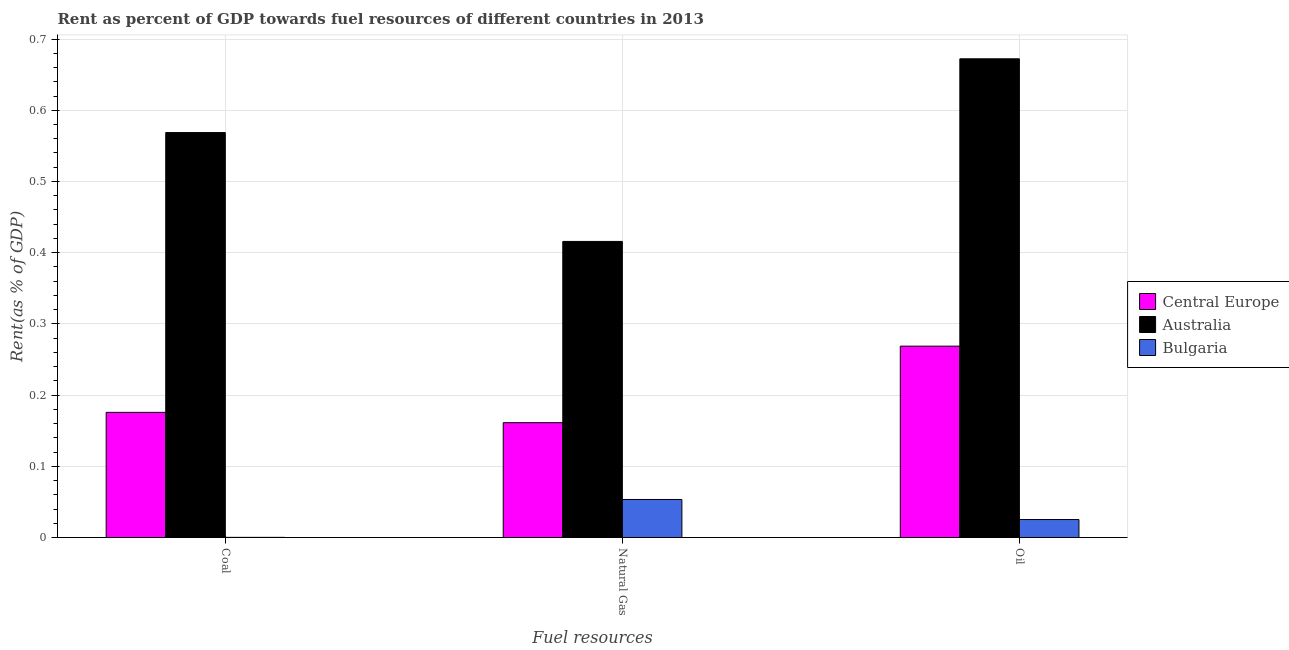Are the number of bars per tick equal to the number of legend labels?
Keep it short and to the point. Yes. How many bars are there on the 3rd tick from the left?
Your answer should be compact. 3. What is the label of the 1st group of bars from the left?
Provide a short and direct response. Coal. What is the rent towards oil in Central Europe?
Make the answer very short. 0.27. Across all countries, what is the maximum rent towards natural gas?
Your answer should be very brief. 0.42. Across all countries, what is the minimum rent towards coal?
Ensure brevity in your answer.  0. In which country was the rent towards oil maximum?
Ensure brevity in your answer.  Australia. What is the total rent towards coal in the graph?
Offer a terse response. 0.74. What is the difference between the rent towards oil in Australia and that in Central Europe?
Ensure brevity in your answer.  0.4. What is the difference between the rent towards oil in Central Europe and the rent towards coal in Bulgaria?
Provide a succinct answer. 0.27. What is the average rent towards natural gas per country?
Give a very brief answer. 0.21. What is the difference between the rent towards natural gas and rent towards oil in Central Europe?
Your response must be concise. -0.11. What is the ratio of the rent towards coal in Bulgaria to that in Australia?
Provide a succinct answer. 0. Is the rent towards oil in Bulgaria less than that in Australia?
Offer a very short reply. Yes. What is the difference between the highest and the second highest rent towards oil?
Offer a terse response. 0.4. What is the difference between the highest and the lowest rent towards coal?
Your response must be concise. 0.57. In how many countries, is the rent towards natural gas greater than the average rent towards natural gas taken over all countries?
Provide a short and direct response. 1. Is it the case that in every country, the sum of the rent towards coal and rent towards natural gas is greater than the rent towards oil?
Ensure brevity in your answer.  Yes. How many bars are there?
Make the answer very short. 9. Are all the bars in the graph horizontal?
Offer a terse response. No. What is the difference between two consecutive major ticks on the Y-axis?
Your response must be concise. 0.1. Does the graph contain any zero values?
Your answer should be compact. No. Does the graph contain grids?
Ensure brevity in your answer.  Yes. Where does the legend appear in the graph?
Make the answer very short. Center right. How are the legend labels stacked?
Your answer should be very brief. Vertical. What is the title of the graph?
Give a very brief answer. Rent as percent of GDP towards fuel resources of different countries in 2013. Does "North America" appear as one of the legend labels in the graph?
Give a very brief answer. No. What is the label or title of the X-axis?
Provide a succinct answer. Fuel resources. What is the label or title of the Y-axis?
Provide a short and direct response. Rent(as % of GDP). What is the Rent(as % of GDP) in Central Europe in Coal?
Offer a terse response. 0.18. What is the Rent(as % of GDP) in Australia in Coal?
Provide a short and direct response. 0.57. What is the Rent(as % of GDP) in Bulgaria in Coal?
Keep it short and to the point. 0. What is the Rent(as % of GDP) in Central Europe in Natural Gas?
Your answer should be very brief. 0.16. What is the Rent(as % of GDP) of Australia in Natural Gas?
Provide a succinct answer. 0.42. What is the Rent(as % of GDP) of Bulgaria in Natural Gas?
Your response must be concise. 0.05. What is the Rent(as % of GDP) in Central Europe in Oil?
Your answer should be compact. 0.27. What is the Rent(as % of GDP) of Australia in Oil?
Provide a succinct answer. 0.67. What is the Rent(as % of GDP) of Bulgaria in Oil?
Your answer should be compact. 0.03. Across all Fuel resources, what is the maximum Rent(as % of GDP) in Central Europe?
Provide a succinct answer. 0.27. Across all Fuel resources, what is the maximum Rent(as % of GDP) of Australia?
Make the answer very short. 0.67. Across all Fuel resources, what is the maximum Rent(as % of GDP) in Bulgaria?
Your answer should be very brief. 0.05. Across all Fuel resources, what is the minimum Rent(as % of GDP) of Central Europe?
Your response must be concise. 0.16. Across all Fuel resources, what is the minimum Rent(as % of GDP) of Australia?
Make the answer very short. 0.42. Across all Fuel resources, what is the minimum Rent(as % of GDP) of Bulgaria?
Your answer should be very brief. 0. What is the total Rent(as % of GDP) in Central Europe in the graph?
Your response must be concise. 0.61. What is the total Rent(as % of GDP) in Australia in the graph?
Provide a succinct answer. 1.66. What is the total Rent(as % of GDP) in Bulgaria in the graph?
Provide a short and direct response. 0.08. What is the difference between the Rent(as % of GDP) of Central Europe in Coal and that in Natural Gas?
Ensure brevity in your answer.  0.01. What is the difference between the Rent(as % of GDP) in Australia in Coal and that in Natural Gas?
Offer a terse response. 0.15. What is the difference between the Rent(as % of GDP) in Bulgaria in Coal and that in Natural Gas?
Provide a short and direct response. -0.05. What is the difference between the Rent(as % of GDP) in Central Europe in Coal and that in Oil?
Offer a very short reply. -0.09. What is the difference between the Rent(as % of GDP) of Australia in Coal and that in Oil?
Offer a terse response. -0.1. What is the difference between the Rent(as % of GDP) in Bulgaria in Coal and that in Oil?
Make the answer very short. -0.03. What is the difference between the Rent(as % of GDP) in Central Europe in Natural Gas and that in Oil?
Your response must be concise. -0.11. What is the difference between the Rent(as % of GDP) in Australia in Natural Gas and that in Oil?
Offer a very short reply. -0.26. What is the difference between the Rent(as % of GDP) of Bulgaria in Natural Gas and that in Oil?
Provide a short and direct response. 0.03. What is the difference between the Rent(as % of GDP) of Central Europe in Coal and the Rent(as % of GDP) of Australia in Natural Gas?
Provide a succinct answer. -0.24. What is the difference between the Rent(as % of GDP) in Central Europe in Coal and the Rent(as % of GDP) in Bulgaria in Natural Gas?
Offer a terse response. 0.12. What is the difference between the Rent(as % of GDP) in Australia in Coal and the Rent(as % of GDP) in Bulgaria in Natural Gas?
Ensure brevity in your answer.  0.52. What is the difference between the Rent(as % of GDP) in Central Europe in Coal and the Rent(as % of GDP) in Australia in Oil?
Your response must be concise. -0.5. What is the difference between the Rent(as % of GDP) in Central Europe in Coal and the Rent(as % of GDP) in Bulgaria in Oil?
Keep it short and to the point. 0.15. What is the difference between the Rent(as % of GDP) in Australia in Coal and the Rent(as % of GDP) in Bulgaria in Oil?
Keep it short and to the point. 0.54. What is the difference between the Rent(as % of GDP) of Central Europe in Natural Gas and the Rent(as % of GDP) of Australia in Oil?
Your answer should be very brief. -0.51. What is the difference between the Rent(as % of GDP) of Central Europe in Natural Gas and the Rent(as % of GDP) of Bulgaria in Oil?
Provide a short and direct response. 0.14. What is the difference between the Rent(as % of GDP) in Australia in Natural Gas and the Rent(as % of GDP) in Bulgaria in Oil?
Ensure brevity in your answer.  0.39. What is the average Rent(as % of GDP) in Central Europe per Fuel resources?
Give a very brief answer. 0.2. What is the average Rent(as % of GDP) in Australia per Fuel resources?
Provide a short and direct response. 0.55. What is the average Rent(as % of GDP) in Bulgaria per Fuel resources?
Your answer should be compact. 0.03. What is the difference between the Rent(as % of GDP) in Central Europe and Rent(as % of GDP) in Australia in Coal?
Make the answer very short. -0.39. What is the difference between the Rent(as % of GDP) in Central Europe and Rent(as % of GDP) in Bulgaria in Coal?
Keep it short and to the point. 0.18. What is the difference between the Rent(as % of GDP) in Australia and Rent(as % of GDP) in Bulgaria in Coal?
Ensure brevity in your answer.  0.57. What is the difference between the Rent(as % of GDP) of Central Europe and Rent(as % of GDP) of Australia in Natural Gas?
Offer a terse response. -0.25. What is the difference between the Rent(as % of GDP) in Central Europe and Rent(as % of GDP) in Bulgaria in Natural Gas?
Offer a very short reply. 0.11. What is the difference between the Rent(as % of GDP) of Australia and Rent(as % of GDP) of Bulgaria in Natural Gas?
Provide a short and direct response. 0.36. What is the difference between the Rent(as % of GDP) in Central Europe and Rent(as % of GDP) in Australia in Oil?
Your answer should be very brief. -0.4. What is the difference between the Rent(as % of GDP) in Central Europe and Rent(as % of GDP) in Bulgaria in Oil?
Provide a succinct answer. 0.24. What is the difference between the Rent(as % of GDP) of Australia and Rent(as % of GDP) of Bulgaria in Oil?
Your answer should be very brief. 0.65. What is the ratio of the Rent(as % of GDP) in Central Europe in Coal to that in Natural Gas?
Provide a short and direct response. 1.09. What is the ratio of the Rent(as % of GDP) in Australia in Coal to that in Natural Gas?
Your answer should be very brief. 1.37. What is the ratio of the Rent(as % of GDP) in Bulgaria in Coal to that in Natural Gas?
Keep it short and to the point. 0. What is the ratio of the Rent(as % of GDP) of Central Europe in Coal to that in Oil?
Your response must be concise. 0.65. What is the ratio of the Rent(as % of GDP) in Australia in Coal to that in Oil?
Make the answer very short. 0.85. What is the ratio of the Rent(as % of GDP) of Bulgaria in Coal to that in Oil?
Make the answer very short. 0.01. What is the ratio of the Rent(as % of GDP) of Central Europe in Natural Gas to that in Oil?
Your response must be concise. 0.6. What is the ratio of the Rent(as % of GDP) in Australia in Natural Gas to that in Oil?
Make the answer very short. 0.62. What is the ratio of the Rent(as % of GDP) of Bulgaria in Natural Gas to that in Oil?
Your answer should be compact. 2.12. What is the difference between the highest and the second highest Rent(as % of GDP) in Central Europe?
Ensure brevity in your answer.  0.09. What is the difference between the highest and the second highest Rent(as % of GDP) of Australia?
Your answer should be very brief. 0.1. What is the difference between the highest and the second highest Rent(as % of GDP) in Bulgaria?
Offer a very short reply. 0.03. What is the difference between the highest and the lowest Rent(as % of GDP) of Central Europe?
Give a very brief answer. 0.11. What is the difference between the highest and the lowest Rent(as % of GDP) of Australia?
Ensure brevity in your answer.  0.26. What is the difference between the highest and the lowest Rent(as % of GDP) of Bulgaria?
Give a very brief answer. 0.05. 